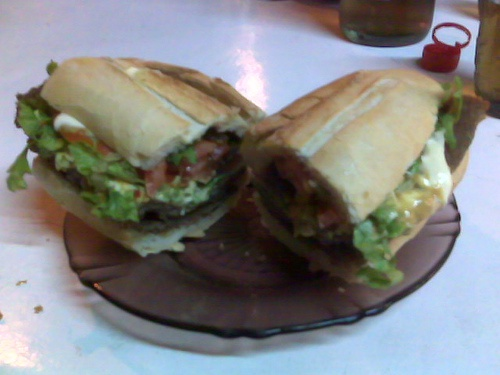Describe the objects in this image and their specific colors. I can see sandwich in darkgray, black, tan, and beige tones, sandwich in darkgray, darkgreen, black, and gray tones, cup in darkgray, black, maroon, and gray tones, bottle in darkgray, black, maroon, and gray tones, and bottle in darkgray, maroon, gray, and black tones in this image. 